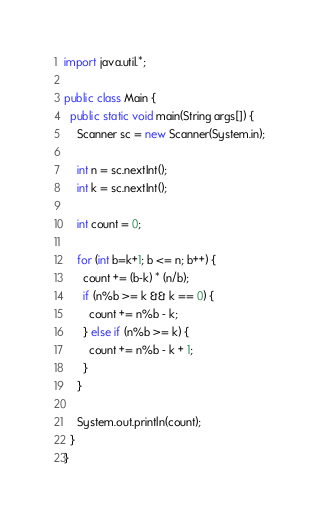Convert code to text. <code><loc_0><loc_0><loc_500><loc_500><_Java_>import java.util.*;

public class Main {
  public static void main(String args[]) {
    Scanner sc = new Scanner(System.in);

    int n = sc.nextInt();
    int k = sc.nextInt();

    int count = 0;

    for (int b=k+1; b <= n; b++) {
      count += (b-k) * (n/b);
      if (n%b >= k && k == 0) {
        count += n%b - k;
      } else if (n%b >= k) {
        count += n%b - k + 1;
      }
    }

    System.out.println(count);
  }
}
</code> 